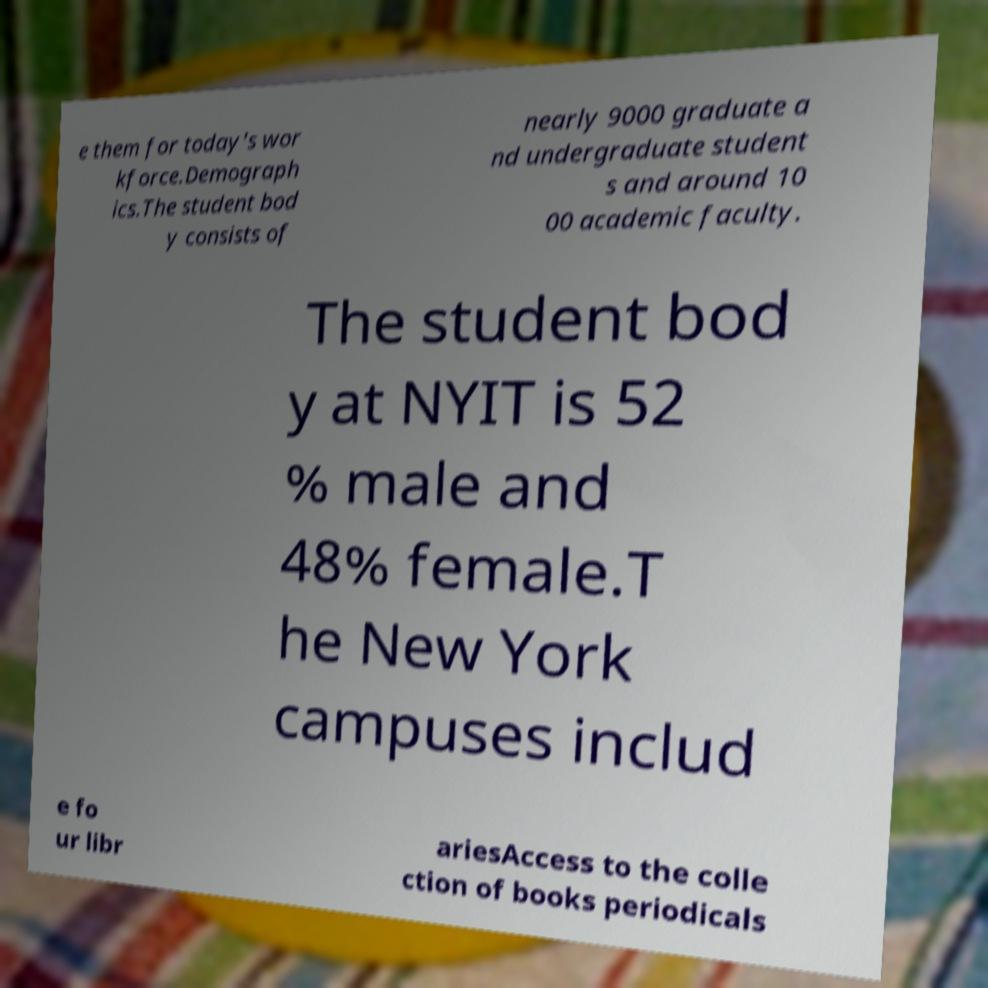There's text embedded in this image that I need extracted. Can you transcribe it verbatim? e them for today's wor kforce.Demograph ics.The student bod y consists of nearly 9000 graduate a nd undergraduate student s and around 10 00 academic faculty. The student bod y at NYIT is 52 % male and 48% female.T he New York campuses includ e fo ur libr ariesAccess to the colle ction of books periodicals 